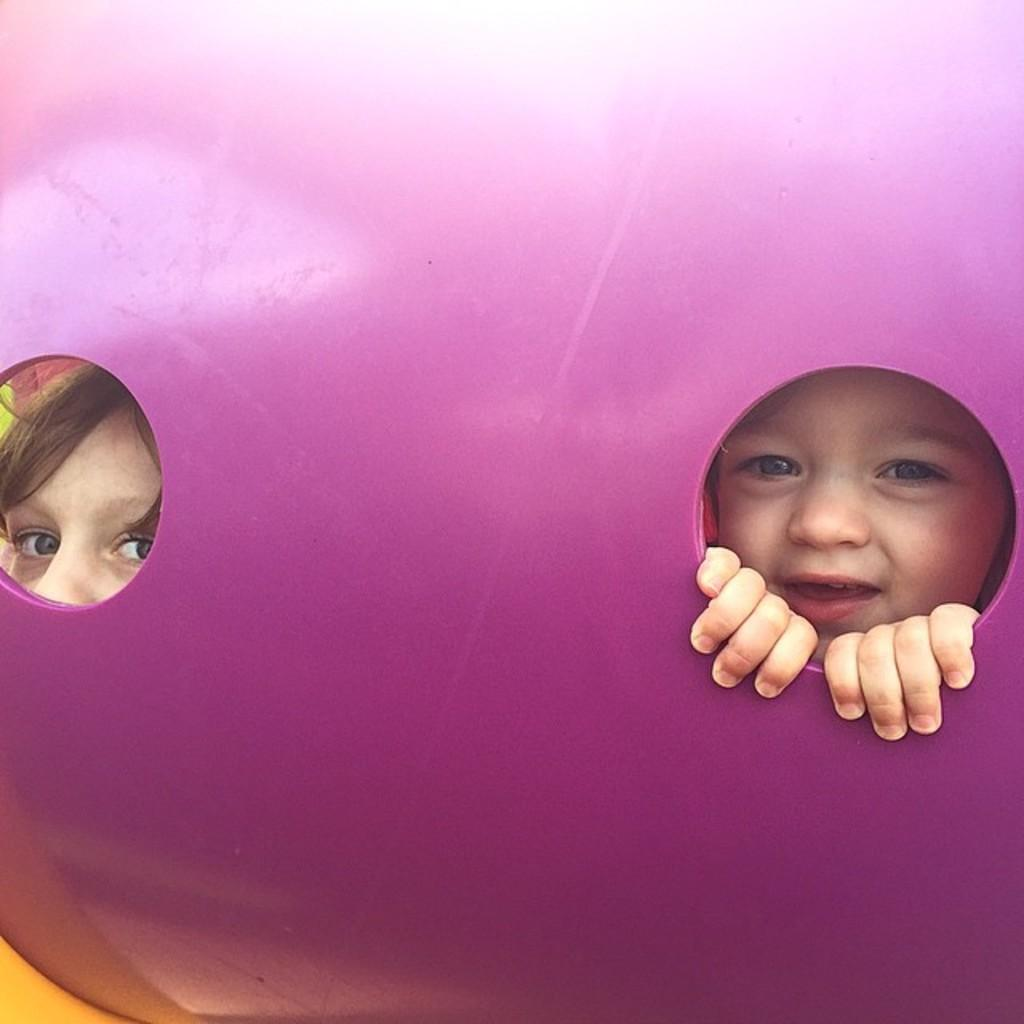How many kids are present in the image? There are two kids in the image. What object are the kids in? The kids are in an object, but the specific object is not mentioned in the facts. Can you describe the time of day when the image was likely taken? The image was likely taken during the day. How many jellyfish can be seen swimming in the image? There are no jellyfish present in the image. Is there a connection between the two kids in the image? The facts provided do not give any information about a connection between the two kids. 